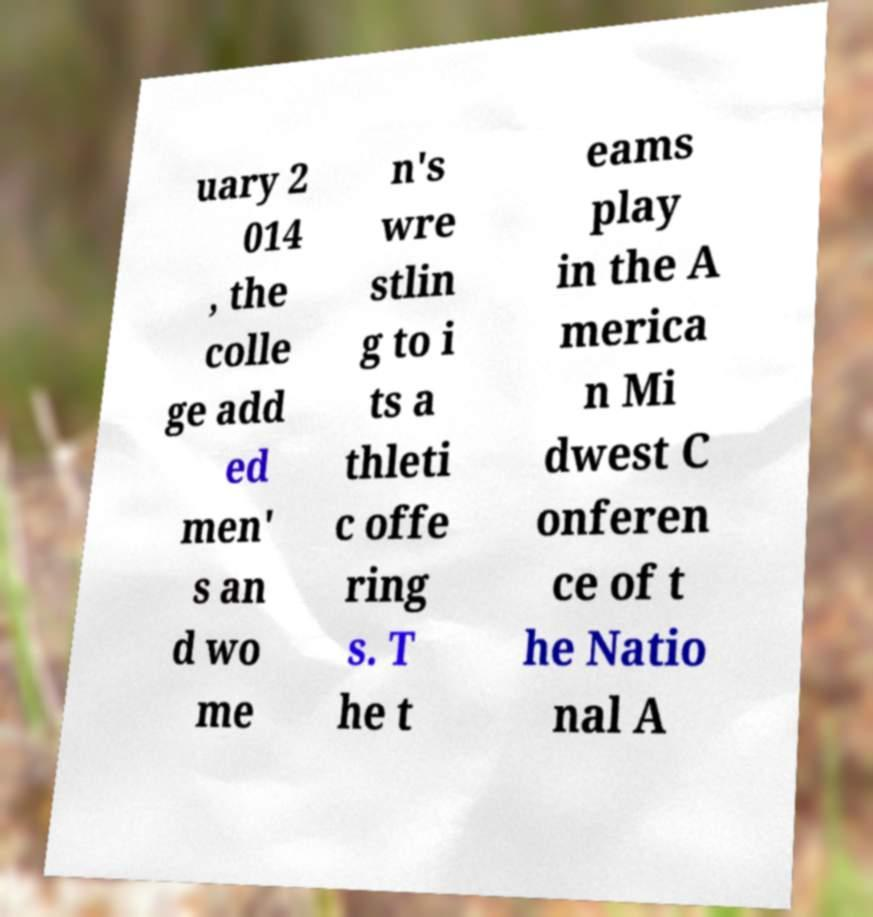What messages or text are displayed in this image? I need them in a readable, typed format. uary 2 014 , the colle ge add ed men' s an d wo me n's wre stlin g to i ts a thleti c offe ring s. T he t eams play in the A merica n Mi dwest C onferen ce of t he Natio nal A 